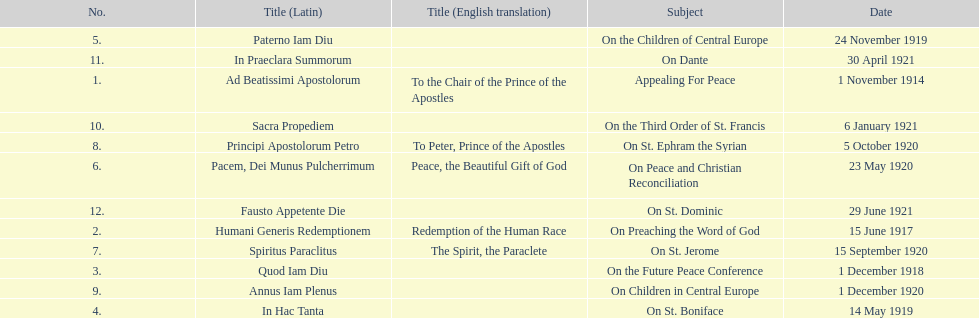Could you help me parse every detail presented in this table? {'header': ['No.', 'Title (Latin)', 'Title (English translation)', 'Subject', 'Date'], 'rows': [['5.', 'Paterno Iam Diu', '', 'On the Children of Central Europe', '24 November 1919'], ['11.', 'In Praeclara Summorum', '', 'On Dante', '30 April 1921'], ['1.', 'Ad Beatissimi Apostolorum', 'To the Chair of the Prince of the Apostles', 'Appealing For Peace', '1 November 1914'], ['10.', 'Sacra Propediem', '', 'On the Third Order of St. Francis', '6 January 1921'], ['8.', 'Principi Apostolorum Petro', 'To Peter, Prince of the Apostles', 'On St. Ephram the Syrian', '5 October 1920'], ['6.', 'Pacem, Dei Munus Pulcherrimum', 'Peace, the Beautiful Gift of God', 'On Peace and Christian Reconciliation', '23 May 1920'], ['12.', 'Fausto Appetente Die', '', 'On St. Dominic', '29 June 1921'], ['2.', 'Humani Generis Redemptionem', 'Redemption of the Human Race', 'On Preaching the Word of God', '15 June 1917'], ['7.', 'Spiritus Paraclitus', 'The Spirit, the Paraclete', 'On St. Jerome', '15 September 1920'], ['3.', 'Quod Iam Diu', '', 'On the Future Peace Conference', '1 December 1918'], ['9.', 'Annus Iam Plenus', '', 'On Children in Central Europe', '1 December 1920'], ['4.', 'In Hac Tanta', '', 'On St. Boniface', '14 May 1919']]} Apart from january, how many encyclicals existed in 1921? 2. 